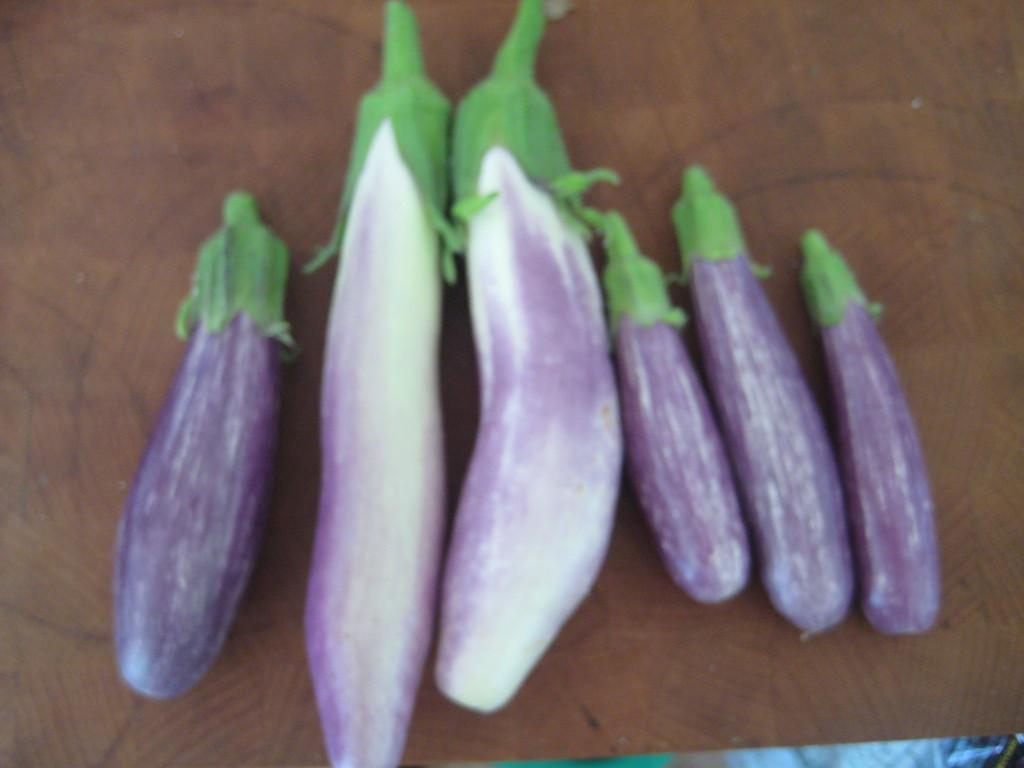What type of vegetable is present in the image? There are brinjals in the image. What is the color of the surface on which the brinjals are placed? The brinjals are placed on a brown surface. What type of dog can be seen playing with the brinjals in the image? There is no dog present in the image, and the brinjals are not being played with. 